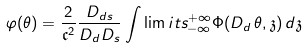Convert formula to latex. <formula><loc_0><loc_0><loc_500><loc_500>\varphi ( \theta ) = \frac { 2 } { \mathfrak { c } ^ { 2 } } \frac { D _ { d s } } { D _ { d } D _ { s } } \int \lim i t s _ { - \infty } ^ { + \infty } \Phi ( D _ { d } \, \theta , \mathfrak { z } ) \, d \mathfrak { z }</formula> 